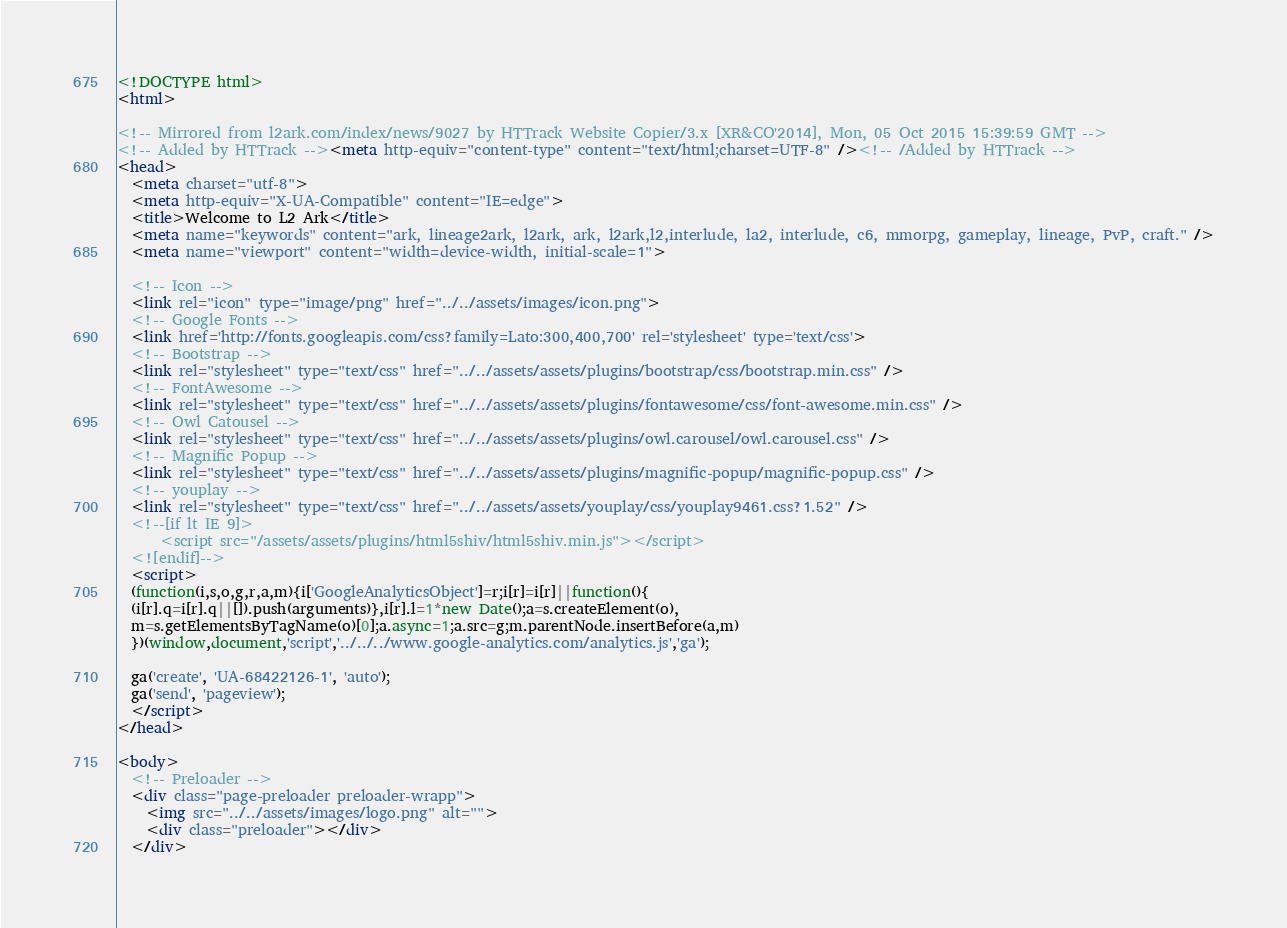Convert code to text. <code><loc_0><loc_0><loc_500><loc_500><_HTML_><!DOCTYPE html>
<html>

<!-- Mirrored from l2ark.com/index/news/9027 by HTTrack Website Copier/3.x [XR&CO'2014], Mon, 05 Oct 2015 15:39:59 GMT -->
<!-- Added by HTTrack --><meta http-equiv="content-type" content="text/html;charset=UTF-8" /><!-- /Added by HTTrack -->
<head>
  <meta charset="utf-8">
  <meta http-equiv="X-UA-Compatible" content="IE=edge">
  <title>Welcome to L2 Ark</title>
  <meta name="keywords" content="ark, lineage2ark, l2ark, ark, l2ark,l2,interlude, la2, interlude, c6, mmorpg, gameplay, lineage, PvP, craft." />
  <meta name="viewport" content="width=device-width, initial-scale=1">

  <!-- Icon -->
  <link rel="icon" type="image/png" href="../../assets/images/icon.png">
  <!-- Google Fonts -->
  <link href='http://fonts.googleapis.com/css?family=Lato:300,400,700' rel='stylesheet' type='text/css'>
  <!-- Bootstrap -->
  <link rel="stylesheet" type="text/css" href="../../assets/assets/plugins/bootstrap/css/bootstrap.min.css" />
  <!-- FontAwesome -->
  <link rel="stylesheet" type="text/css" href="../../assets/assets/plugins/fontawesome/css/font-awesome.min.css" />
  <!-- Owl Catousel -->
  <link rel="stylesheet" type="text/css" href="../../assets/assets/plugins/owl.carousel/owl.carousel.css" />
  <!-- Magnific Popup -->
  <link rel="stylesheet" type="text/css" href="../../assets/assets/plugins/magnific-popup/magnific-popup.css" />
  <!-- youplay -->
  <link rel="stylesheet" type="text/css" href="../../assets/assets/youplay/css/youplay9461.css?1.52" />
  <!--[if lt IE 9]>
      <script src="/assets/assets/plugins/html5shiv/html5shiv.min.js"></script>
  <![endif]-->
  <script>
  (function(i,s,o,g,r,a,m){i['GoogleAnalyticsObject']=r;i[r]=i[r]||function(){
  (i[r].q=i[r].q||[]).push(arguments)},i[r].l=1*new Date();a=s.createElement(o),
  m=s.getElementsByTagName(o)[0];a.async=1;a.src=g;m.parentNode.insertBefore(a,m)
  })(window,document,'script','../../../www.google-analytics.com/analytics.js','ga');

  ga('create', 'UA-68422126-1', 'auto');
  ga('send', 'pageview');
  </script>
</head>

<body>
  <!-- Preloader -->
  <div class="page-preloader preloader-wrapp">
    <img src="../../assets/images/logo.png" alt="">
    <div class="preloader"></div>
  </div></code> 